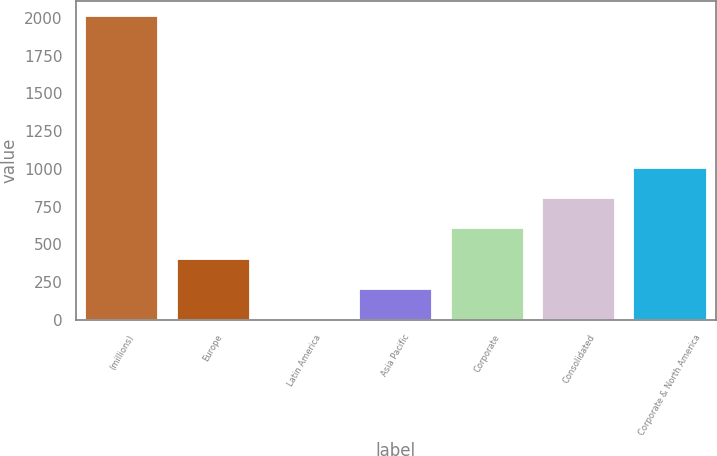<chart> <loc_0><loc_0><loc_500><loc_500><bar_chart><fcel>(millions)<fcel>Europe<fcel>Latin America<fcel>Asia Pacific<fcel>Corporate<fcel>Consolidated<fcel>Corporate & North America<nl><fcel>2013<fcel>403.4<fcel>1<fcel>202.2<fcel>604.6<fcel>805.8<fcel>1007<nl></chart> 